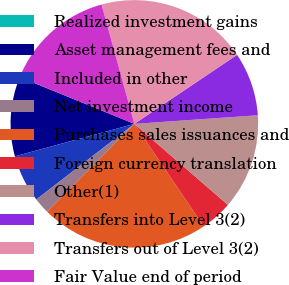<chart> <loc_0><loc_0><loc_500><loc_500><pie_chart><fcel>Realized investment gains<fcel>Asset management fees and<fcel>Included in other<fcel>Net investment income<fcel>Purchases sales issuances and<fcel>Foreign currency translation<fcel>Other(1)<fcel>Transfers into Level 3(2)<fcel>Transfers out of Level 3(2)<fcel>Fair Value end of period<nl><fcel>0.02%<fcel>10.39%<fcel>6.24%<fcel>2.09%<fcel>21.93%<fcel>4.17%<fcel>12.46%<fcel>8.31%<fcel>19.85%<fcel>14.54%<nl></chart> 